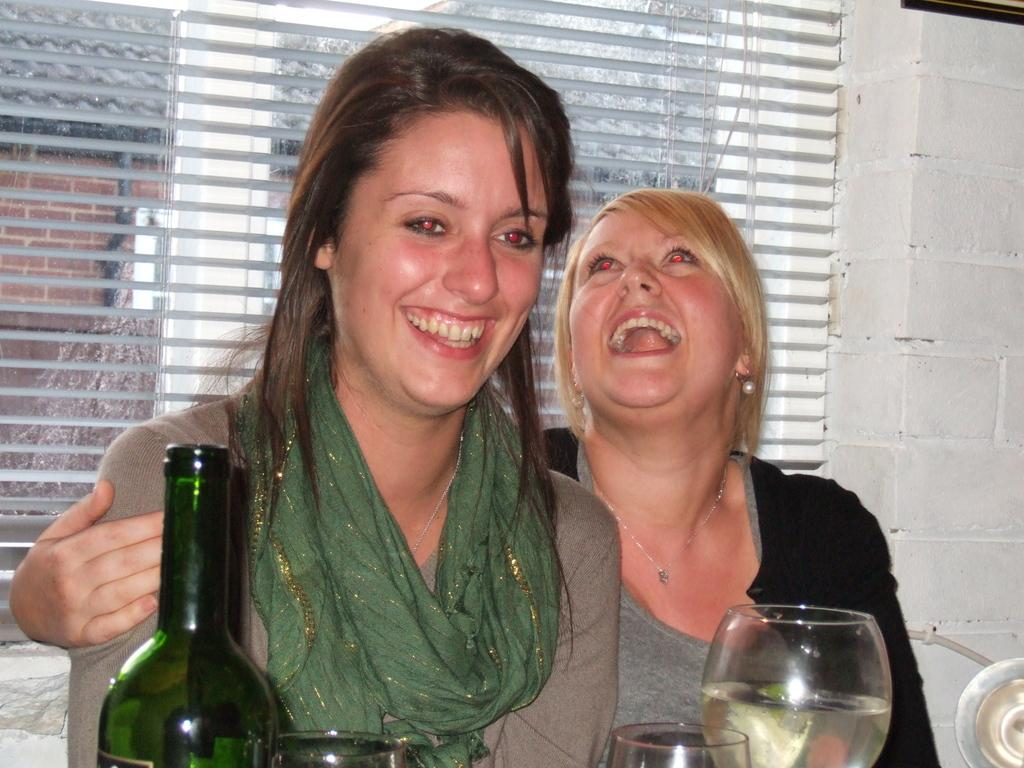How many people are in the image? There are two persons in the image. What objects can be seen in the image related to drinking? There is a bottle and a glass in the image. What can be seen in the background of the image? There is a wall and a window in the background of the image. What is visible through the window in the image? There is a house visible through the window. What type of glove is being used to test the theory in the image? There is no glove or theory present in the image; it features two people, a bottle, a glass, a wall, a window, and a house visible through the window. 